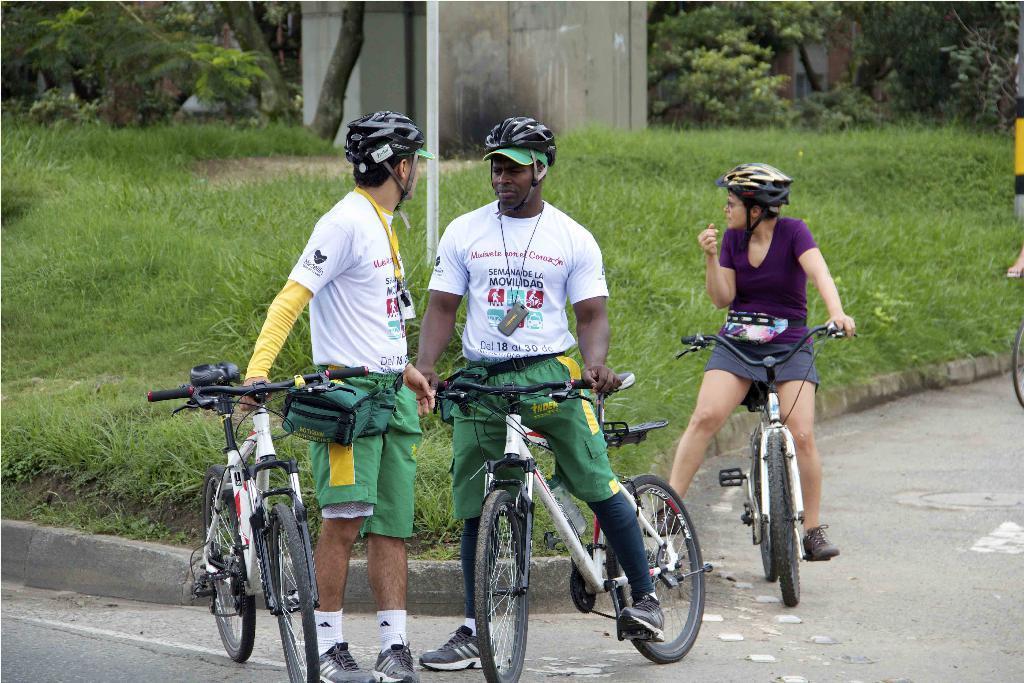Please provide a concise description of this image. There are three members in this picture. All of them are riding bicycles, wearing helmets, on the road. In the background, there is a pole, grass and a wall here. 